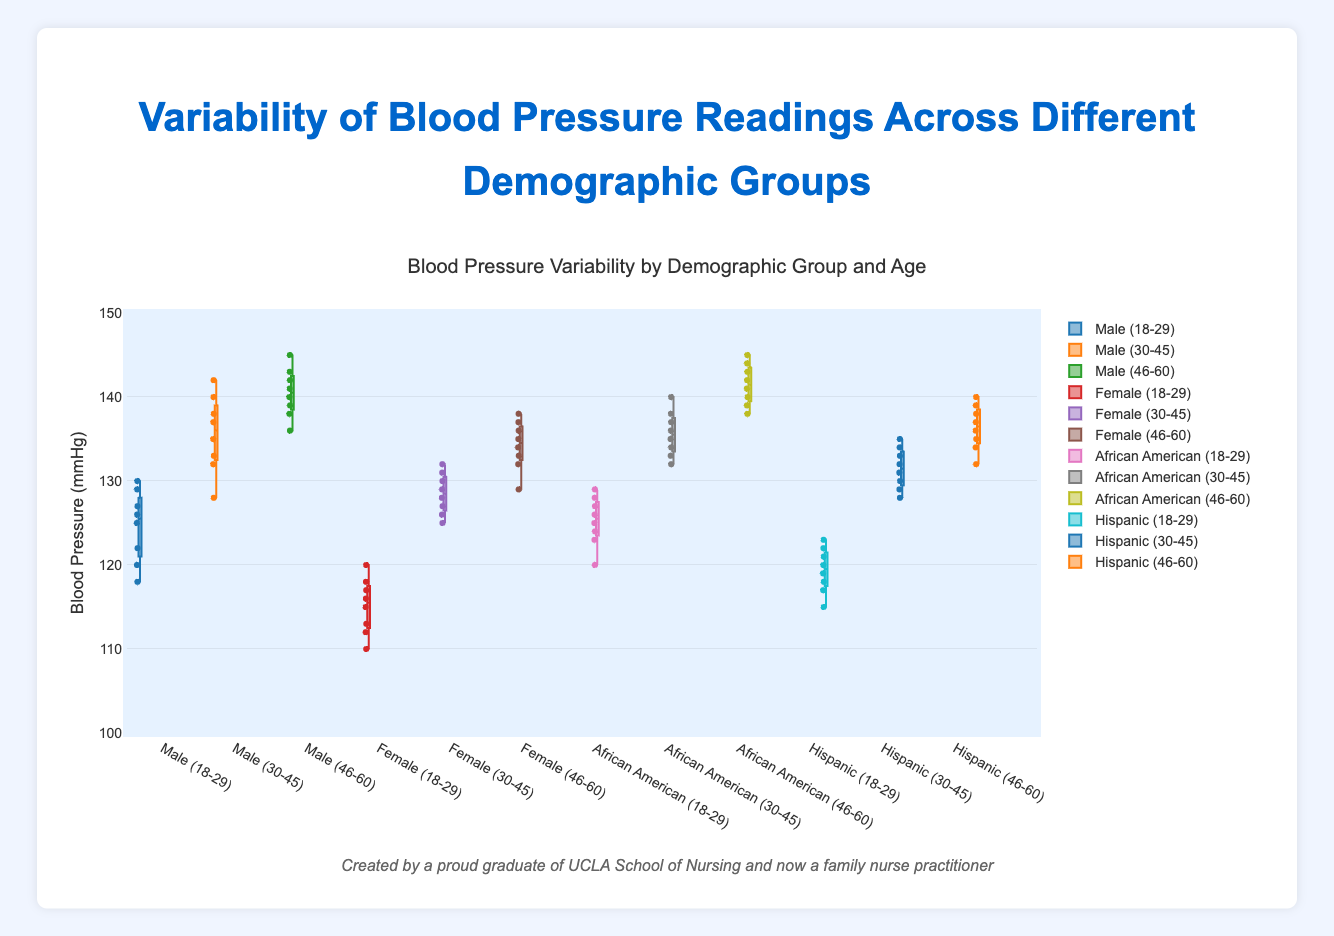What is the title of the plot? The title is at the top of the figure and gives a summary of what the figure is about.
Answer: Blood Pressure Variability by Demographic Group and Age What is the range of blood pressure values depicted in the plot? The y-axis shows the range of blood pressure values.
Answer: 100 to 150 mmHg Which group has the highest median blood pressure reading? Check the line inside the boxes, which represents the median. Comparatively, the "Male 46-60" and "African American 46-60" groups have the highest medians.
Answer: Male 46-60 and African American 46-60 What’s the median blood pressure reading for females aged 30-45? Locate the "Female (30-45)" box in the plot and check the line inside the box which represents the median.
Answer: Approximately 128 mmHg What age group shows the highest variability in blood pressure readings for males? Look at the width of the boxes (interquartile range) and the range of the "whiskers" for male groups. "Male (30-45)" shows higher variability compared to other male groups.
Answer: Male (30-45) How does the blood pressure variability for Hispanic individuals aged 30-45 compare with those aged 46-60? Compare the length of the boxes and the whiskers for "Hispanic (30-45)" and "Hispanic (46-60)". The boxes for both groups are relatively similar, but "Hispanic (30-45)" might indicate slightly lesser variability.
Answer: Hispanic 30-45 Which group has the least variation in blood pressure readings? Look for the group with the smallest box and shortest whiskers. "Female 18-29" has the least variation.
Answer: Female 18-29 What are the lower and upper quartiles for African Americans aged 18-29? The lower quartile (Q1) is the bottom of the box, and the upper quartile (Q3) is the top of the box for "African American (18-29)".
Answer: Approximately 123 mmHg and 127 mmHg How do the median blood pressure readings for the "Male 18-29" and "Female 18-29" groups compare? Check the lines in the middle of the boxes. The median for "Male 18-29" is higher than "Female 18-29".
Answer: Male 18-29 median is higher What group and age have outliers in their blood pressure readings? Look for any individual points outside the box and whiskers. Groups with outliers include "Male (30-45)", "Male (46-60)", "African American (46-60)" and "Hispanic (46-60)".
Answer: Male (30-45), Male (46-60), African American (46-60), Hispanic (46-60) 